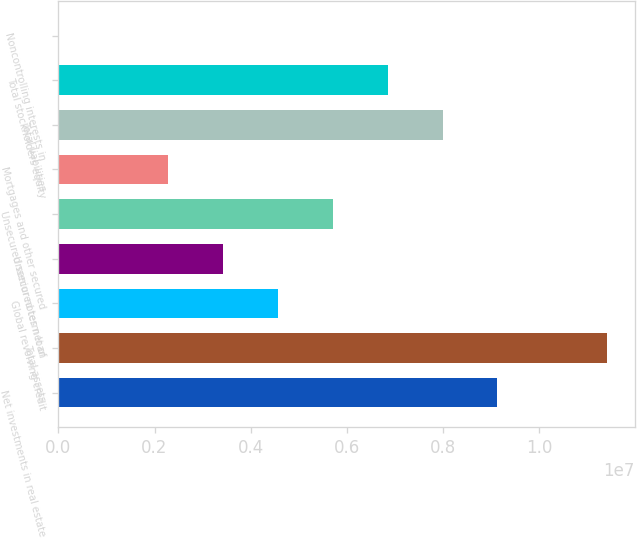<chart> <loc_0><loc_0><loc_500><loc_500><bar_chart><fcel>Net investments in real estate<fcel>Total assets<fcel>Global revolving credit<fcel>Unsecured term loan<fcel>Unsecured senior notes net of<fcel>Mortgages and other secured<fcel>Total liabilities<fcel>Total stockholders equity<fcel>Noncontrolling interests in<nl><fcel>9.1342e+06<fcel>1.14161e+07<fcel>4.57048e+06<fcel>3.42955e+06<fcel>5.71141e+06<fcel>2.28862e+06<fcel>7.99327e+06<fcel>6.85234e+06<fcel>6758<nl></chart> 